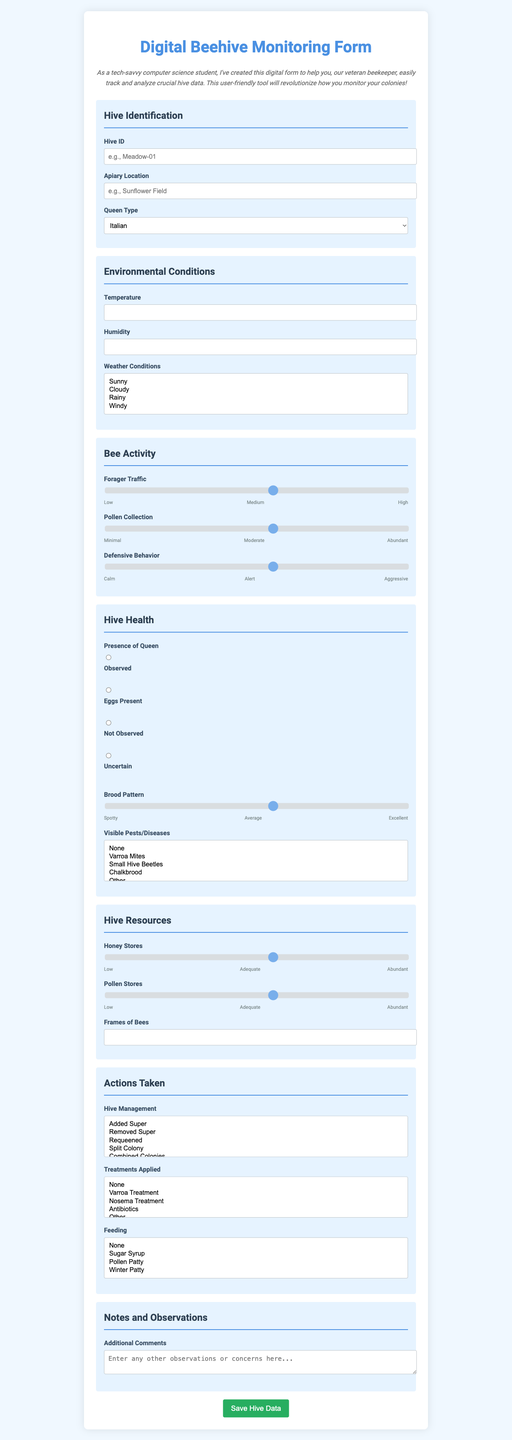What is the form title? The title of the form is stated at the top of the document.
Answer: Digital Beehive Monitoring Form What is the placeholder for the Hive ID field? The placeholder provides an example of what to enter in the Hive ID field.
Answer: e.g., Meadow-01 What options are available for Queen Type? The Queen Type dropdown includes various types of bees for selection.
Answer: Italian, Carniolan, Buckfast, Russian, Other What is the maximum temperature limit provided for monitoring? The maximum temperature is specified in the environmental conditions section of the form.
Answer: 50 How many labels are present for the Forager Traffic slider? The number of labels indicates the possible levels for the slider input.
Answer: 3 What is noted in the submission confirmation message? This message provides feedback after submitting the form and indicates what happened to the data.
Answer: Great job! Your hive data has been successfully saved to the cloud Which field indicates the presence of a queen? The option details the status of the queen's presence in the hive.
Answer: Presence of Queen How many frames of bees can be entered as part of the Hive Resources? This specifies the range of frames that can be inputted in the form.
Answer: 20 What type of weather conditions can be selected? The specified weather options are crucial for assessing hive environment.
Answer: Sunny, Cloudy, Rainy, Windy 